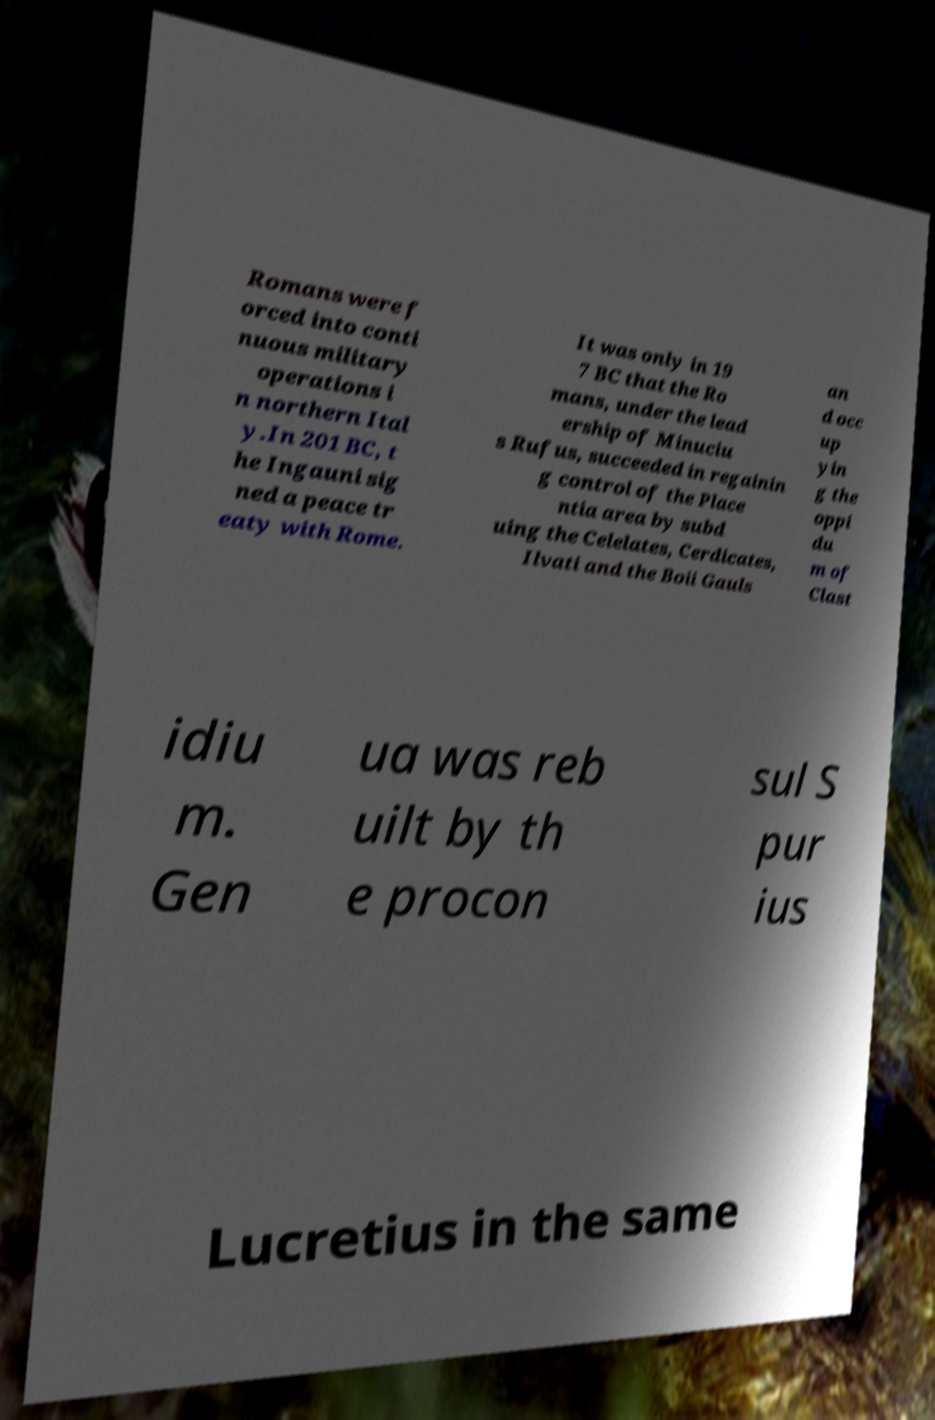Please identify and transcribe the text found in this image. Romans were f orced into conti nuous military operations i n northern Ital y.In 201 BC, t he Ingauni sig ned a peace tr eaty with Rome. It was only in 19 7 BC that the Ro mans, under the lead ership of Minuciu s Rufus, succeeded in regainin g control of the Place ntia area by subd uing the Celelates, Cerdicates, Ilvati and the Boii Gauls an d occ up yin g the oppi du m of Clast idiu m. Gen ua was reb uilt by th e procon sul S pur ius Lucretius in the same 